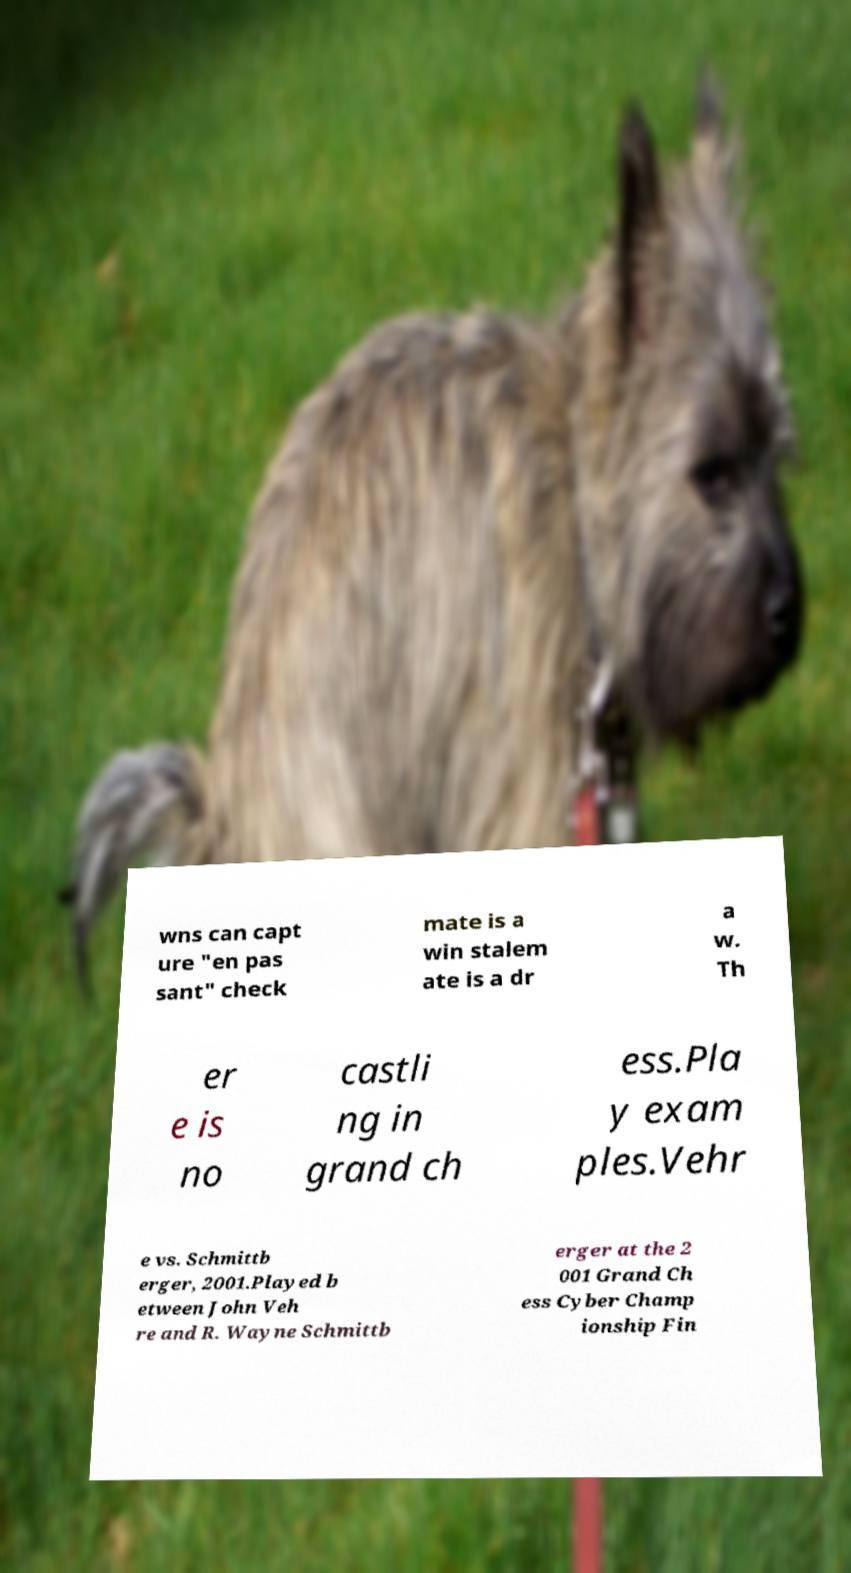Can you accurately transcribe the text from the provided image for me? wns can capt ure "en pas sant" check mate is a win stalem ate is a dr a w. Th er e is no castli ng in grand ch ess.Pla y exam ples.Vehr e vs. Schmittb erger, 2001.Played b etween John Veh re and R. Wayne Schmittb erger at the 2 001 Grand Ch ess Cyber Champ ionship Fin 